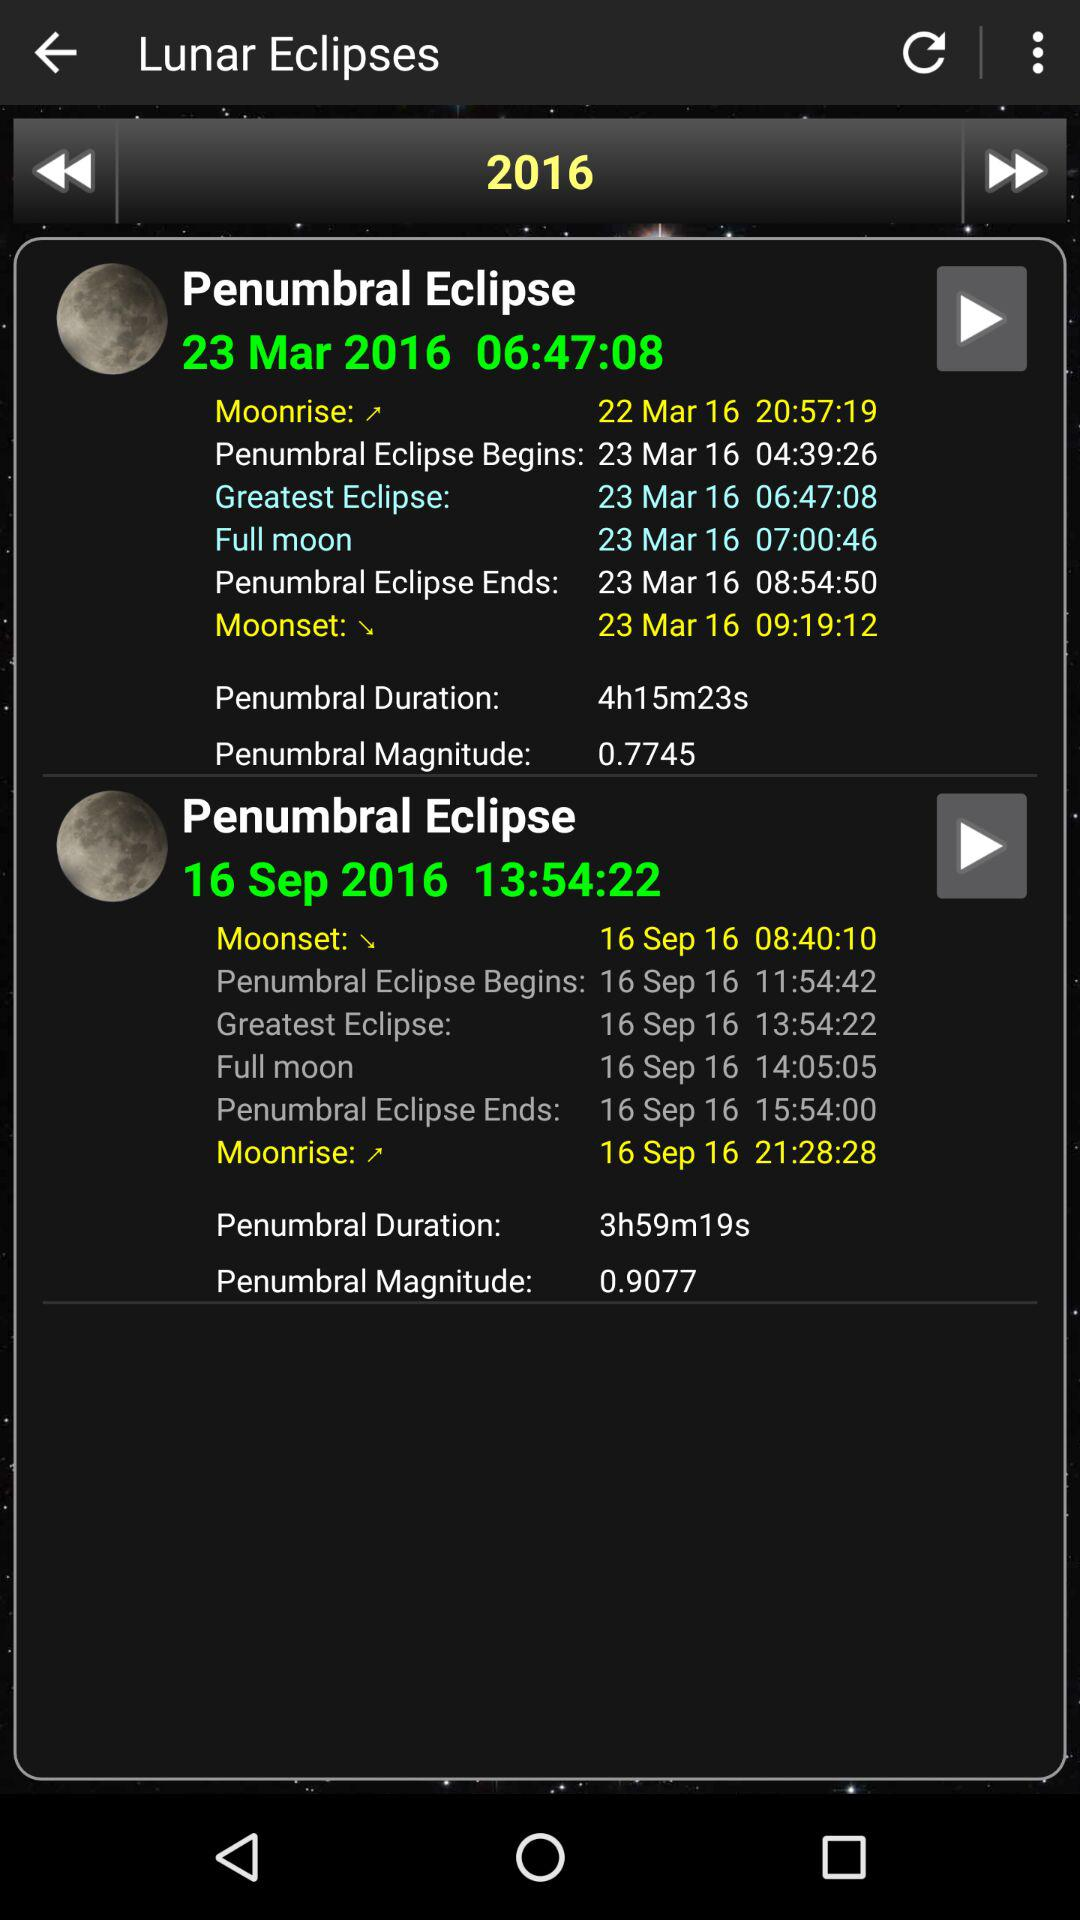What is the penumbral magnitude of the March 23rd eclipse? The penumbral magnitude is 0.7745. 